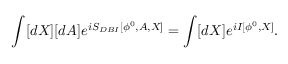Convert formula to latex. <formula><loc_0><loc_0><loc_500><loc_500>\int [ d X ] [ d A ] e ^ { i S _ { D B I } [ \phi ^ { 0 } , A , X ] } = \int [ d X ] e ^ { i I [ \phi ^ { 0 } , X ] } .</formula> 